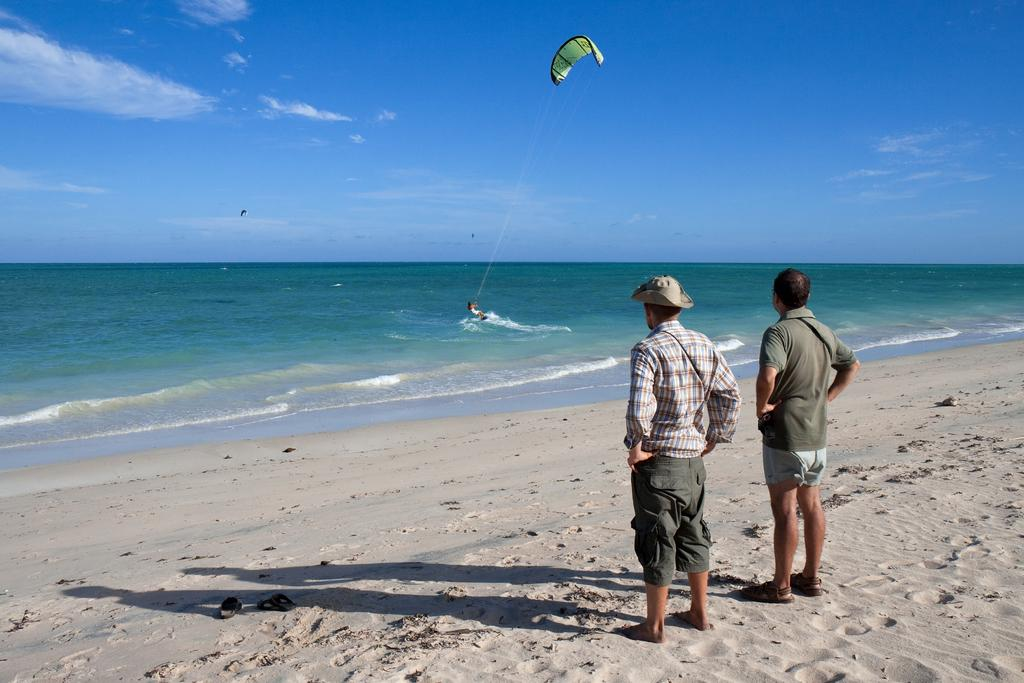How many people are in the image? There are two men and one person in the image, making a total of three people. What is the setting of the image? The men are standing on the sand in front of a beach. What is the person holding in the image? The person is holding a parachute. How many trees can be seen in the image? There are no trees visible in the image; it features two men standing on the sand and a person holding a parachute in front of a beach. 